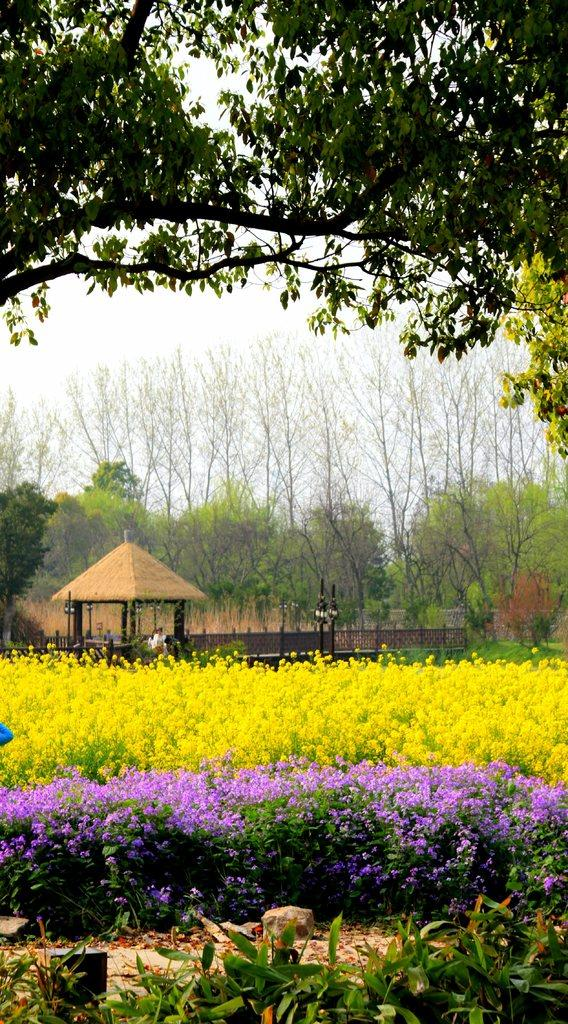What can be seen in the foreground of the picture? There are plants and trees in the foreground of the picture. What is located in the center of the picture? In the center of the picture, there are plants, flowers, and a house. What is visible in the background of the picture? There are trees in the background of the picture. How would you describe the sky in the image? The sky is cloudy in the image. What type of discovery was made by the bird in the image? There is no bird present in the image, so no discovery can be attributed to a bird. What is the mass of the plants in the image? The mass of the plants cannot be determined from the image alone, as it does not provide any information about their size or weight. 